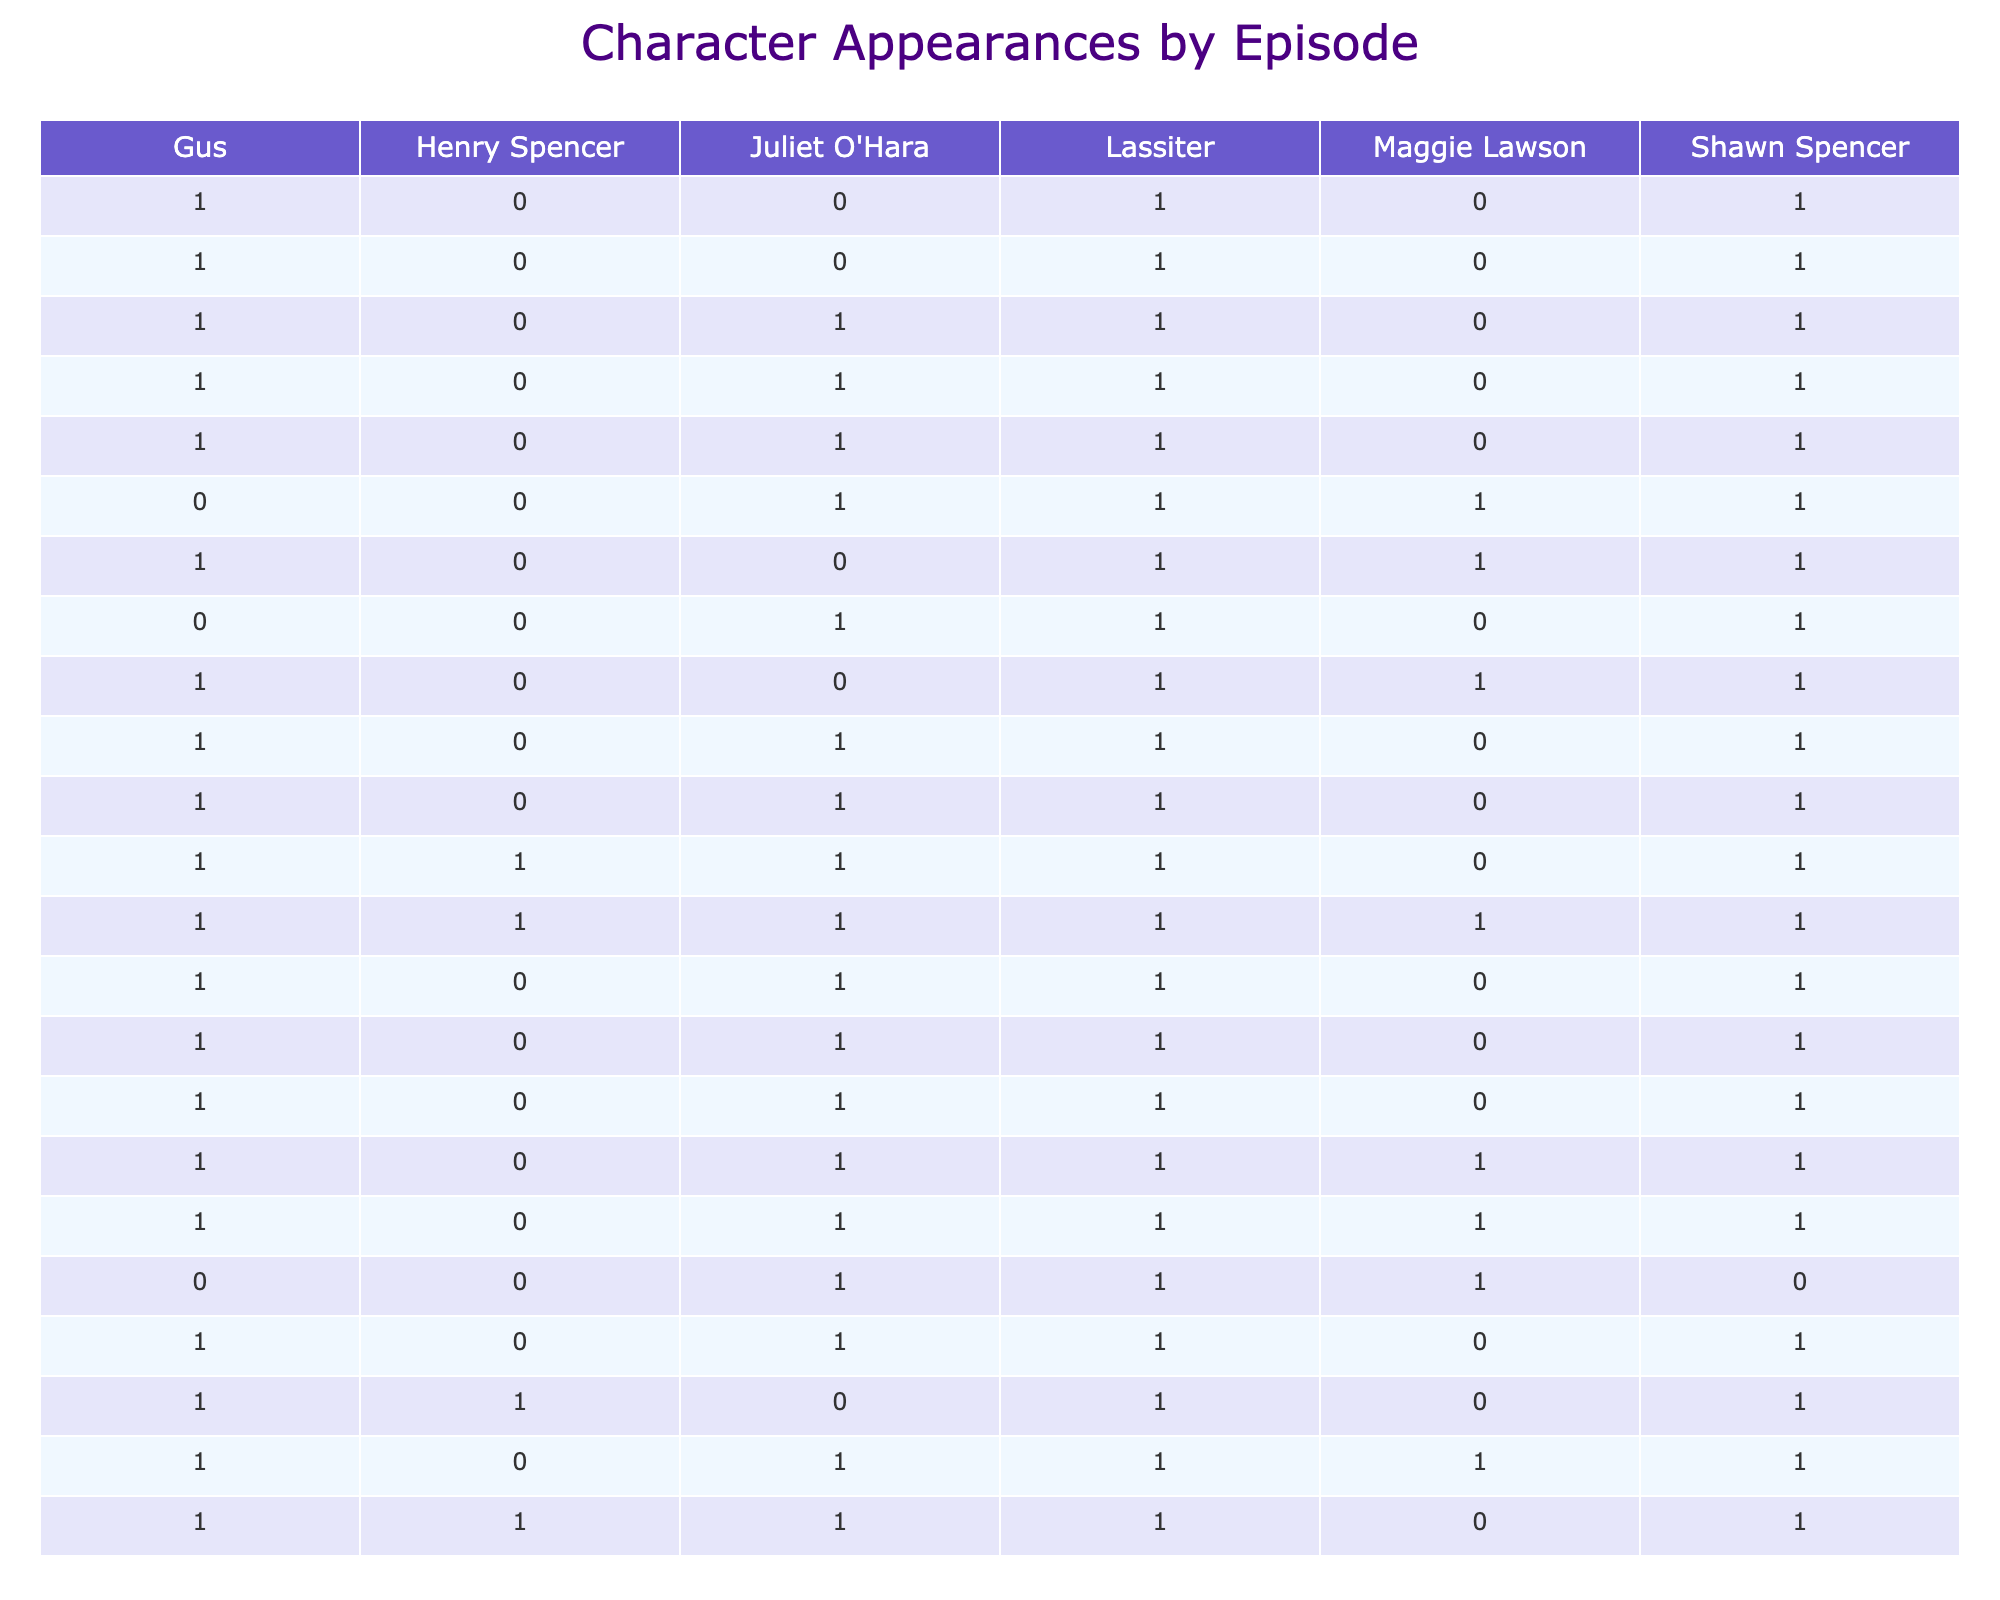What is the total number of appearances for Shawn Spencer in Season 1? In Season 1, there are 13 episodes listed. Shawn Spencer appears in every episode, so the total number of appearances is 13
Answer: 13 How many episodes did Gus appear in? By examining the table, Gus appears in 11 episodes during Season 1, specifically excluding episodes 1.06 and 1.08
Answer: 11 Did Juliet O'Hara appear in more episodes than Henry Spencer? Juliet O'Hara appeared in 9 episodes during Season 1 while Henry Spencer appeared in 4 episodes, thus Juliet has more appearances
Answer: Yes What is the average number of appearances of Lassiter across all episodes in Season 1? Lassiter appears in a total of 8 out of 13 episodes in Season 1. To find the average number of appearances, it remains simply 8 since each episode is considered equally
Answer: 8 In how many episodes did both Shawn and Gus appear together? Both Shawn and Gus appeared together in all episodes of Season 1 except for 1.06 and 1.08, giving them 11 episodes as a pair
Answer: 11 How many times did Maggie Lawson appear in Season 1? Maggie Lawson appeared in 5 episodes in Season 1, which can be counted directly by referencing her column in the table
Answer: 5 What is the difference in the number of appearances between Lassiter and Juliet O'Hara across the first two seasons? Lassiter appeared in 14 episodes across Seasons 1 and 2 (11 in Season 1 and 3 in Season 2). Juliet appeared in 12 episodes during the same period (9 in Season 1 and 3 in Season 2). The difference is 2, meaning Lassiter appears in 2 more episodes than Juliet
Answer: 2 How many total character appearances are there in episode 2.01? For episode 2.01, there are four characters that appeared: Shawn (1), Gus (1), Juliet (1), and Lassiter (1). Adding these gives a total of 4 appearances
Answer: 4 Was there any episode in Season 1 where Shawn did not appear? No, Shawn Spencer appeared in all episodes in Season 1 as confirmed by his presence in every row of the table for that season
Answer: No 